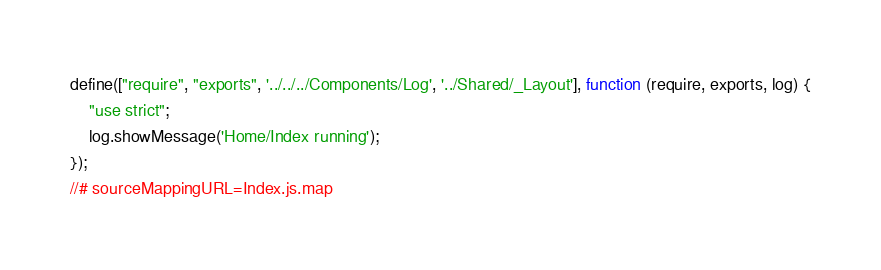Convert code to text. <code><loc_0><loc_0><loc_500><loc_500><_JavaScript_>define(["require", "exports", '../../../Components/Log', '../Shared/_Layout'], function (require, exports, log) {
    "use strict";
    log.showMessage('Home/Index running');
});
//# sourceMappingURL=Index.js.map</code> 